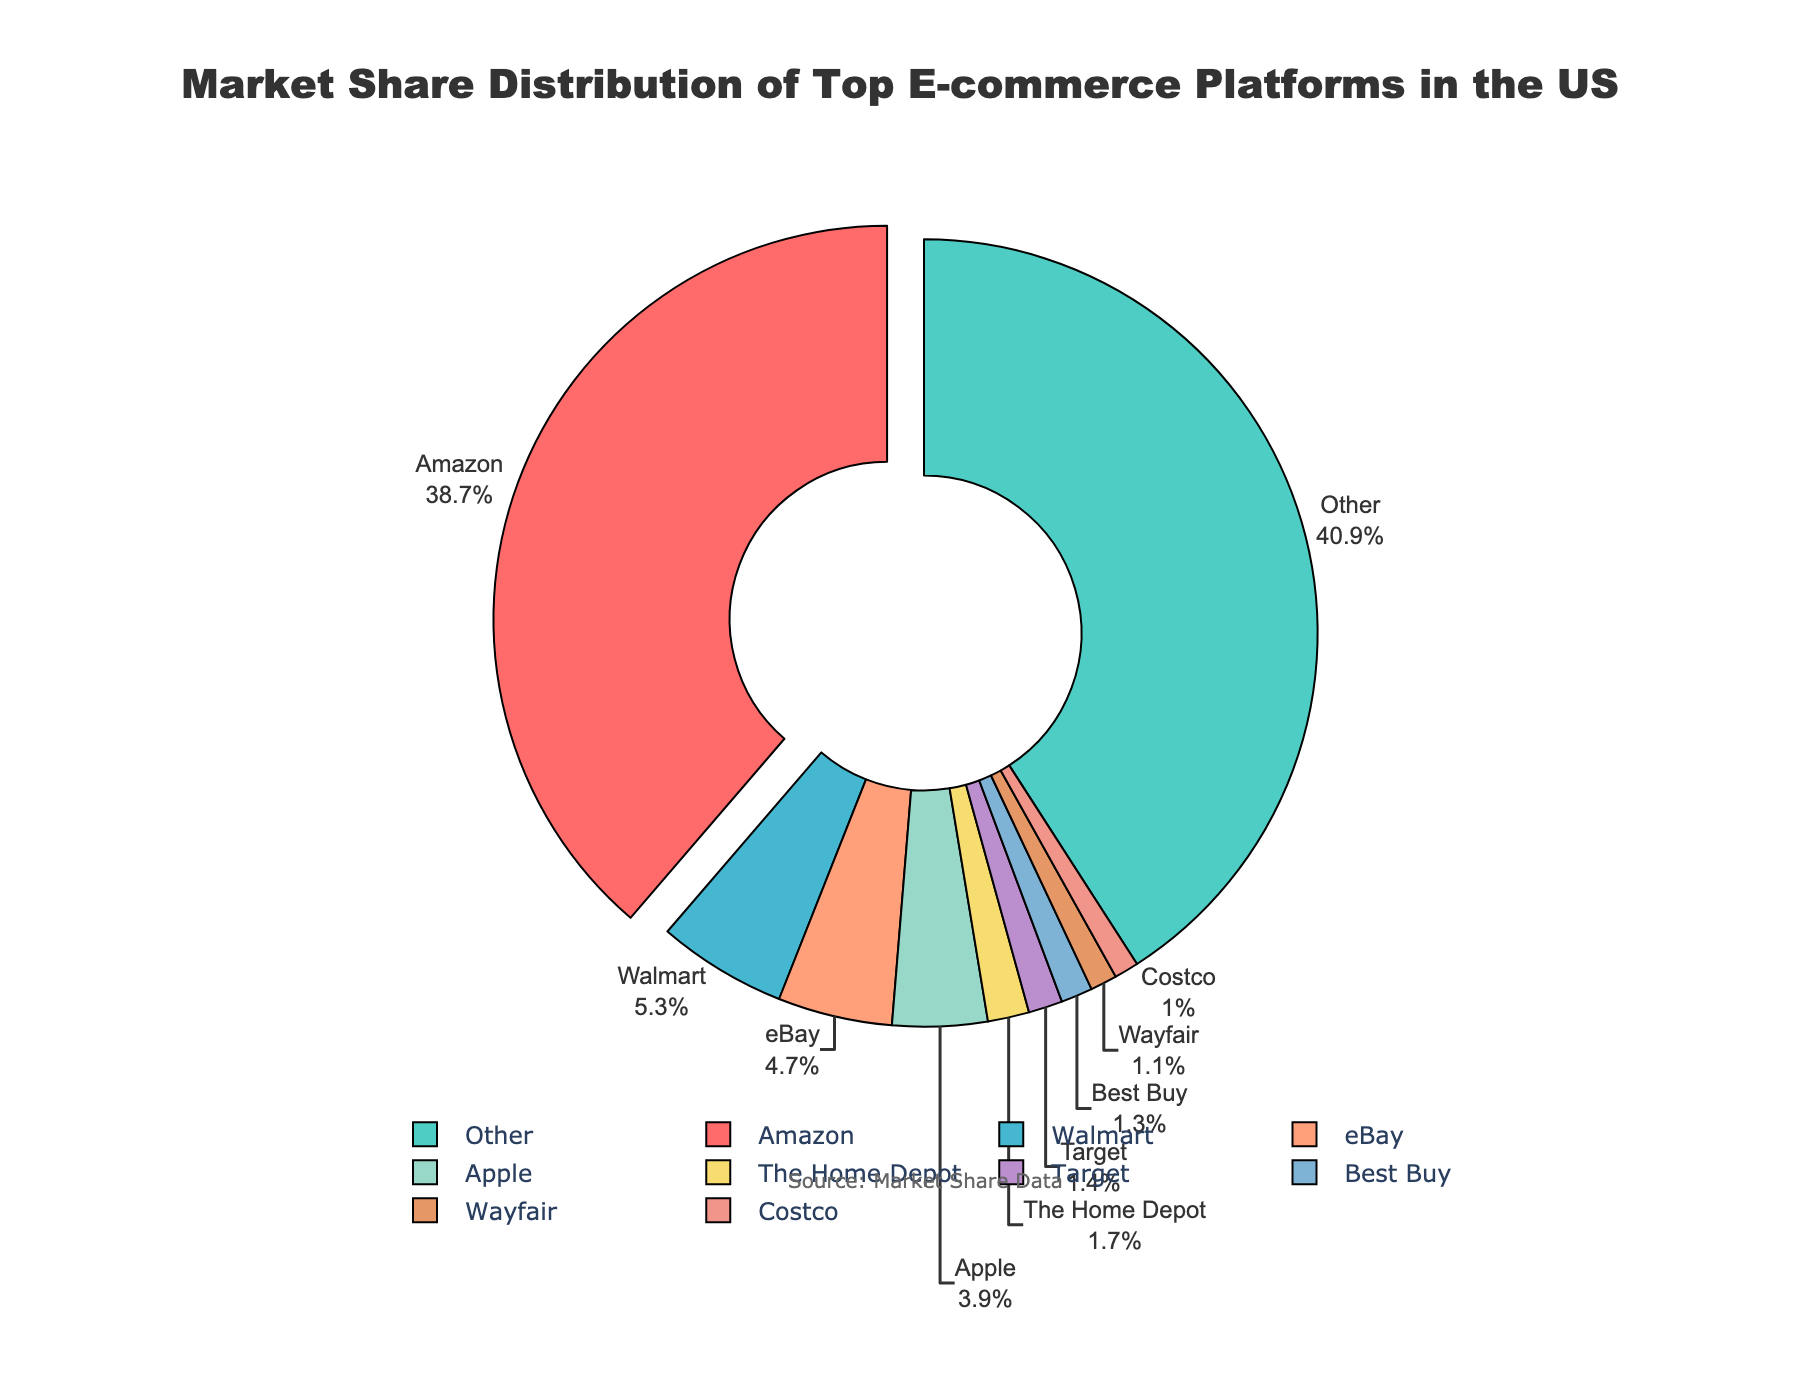What is the market share of Amazon? The figure shows that Amazon has the largest market share among the e-commerce platforms. By looking at the slice representing Amazon, we can see the percentage.
Answer: 38.7% What is the combined market share of Walmart and eBay? To find the combined market share, we add Walmart's market share (5.3%) to eBay's market share (4.7%). Therefore, 5.3% + 4.7% = 10.0%.
Answer: 10.0% Which platform has a greater market share, Apple or The Home Depot? By comparing the two slices on the pie chart, we can see that Apple has a larger slice than The Home Depot. Apple has a market share of 3.9%, while The Home Depot has 1.7%.
Answer: Apple What is the total market share of platforms other than the top 10? The “Other” category covers all platforms excluding the top 10. By looking at the figure, we find that "Other" represents 37.4% of the market.
Answer: 37.4% How much larger is Amazon's market share compared to Best Buy's market share? Amazon's market share (38.7%) minus Best Buy's market share (1.3%) gives the difference. Therefore, 38.7% - 1.3% = 37.4%.
Answer: 37.4% What percentage of the market do Chewy, Macy's, and Lowe's combine to represent? Add up the market shares of Chewy (0.7%), Macy's (0.6%), and Lowe's (0.5%). Therefore, 0.7% + 0.6% + 0.5% = 1.8%.
Answer: 1.8% Out of Best Buy and Wayfair, which has a smaller market share and by how much? Comparing the slices, Wayfair has a smaller market share (1.1%) compared to Best Buy (1.3%). The difference is 1.3% - 1.1% = 0.2%.
Answer: Wayfair, by 0.2% Which color represents Amazon on the pie chart? The pie chart uses different colors for each platform, and Amazon's slice, which is emphasized by being slightly pulled out, is represented in red.
Answer: Red Does the market share of Costco exceed that of Etsy? By looking at the chart, we observe that Costco has a market share of 1.0% and Etsy has 0.9%. Hence, the market share of Costco does exceed that of Etsy.
Answer: Yes 